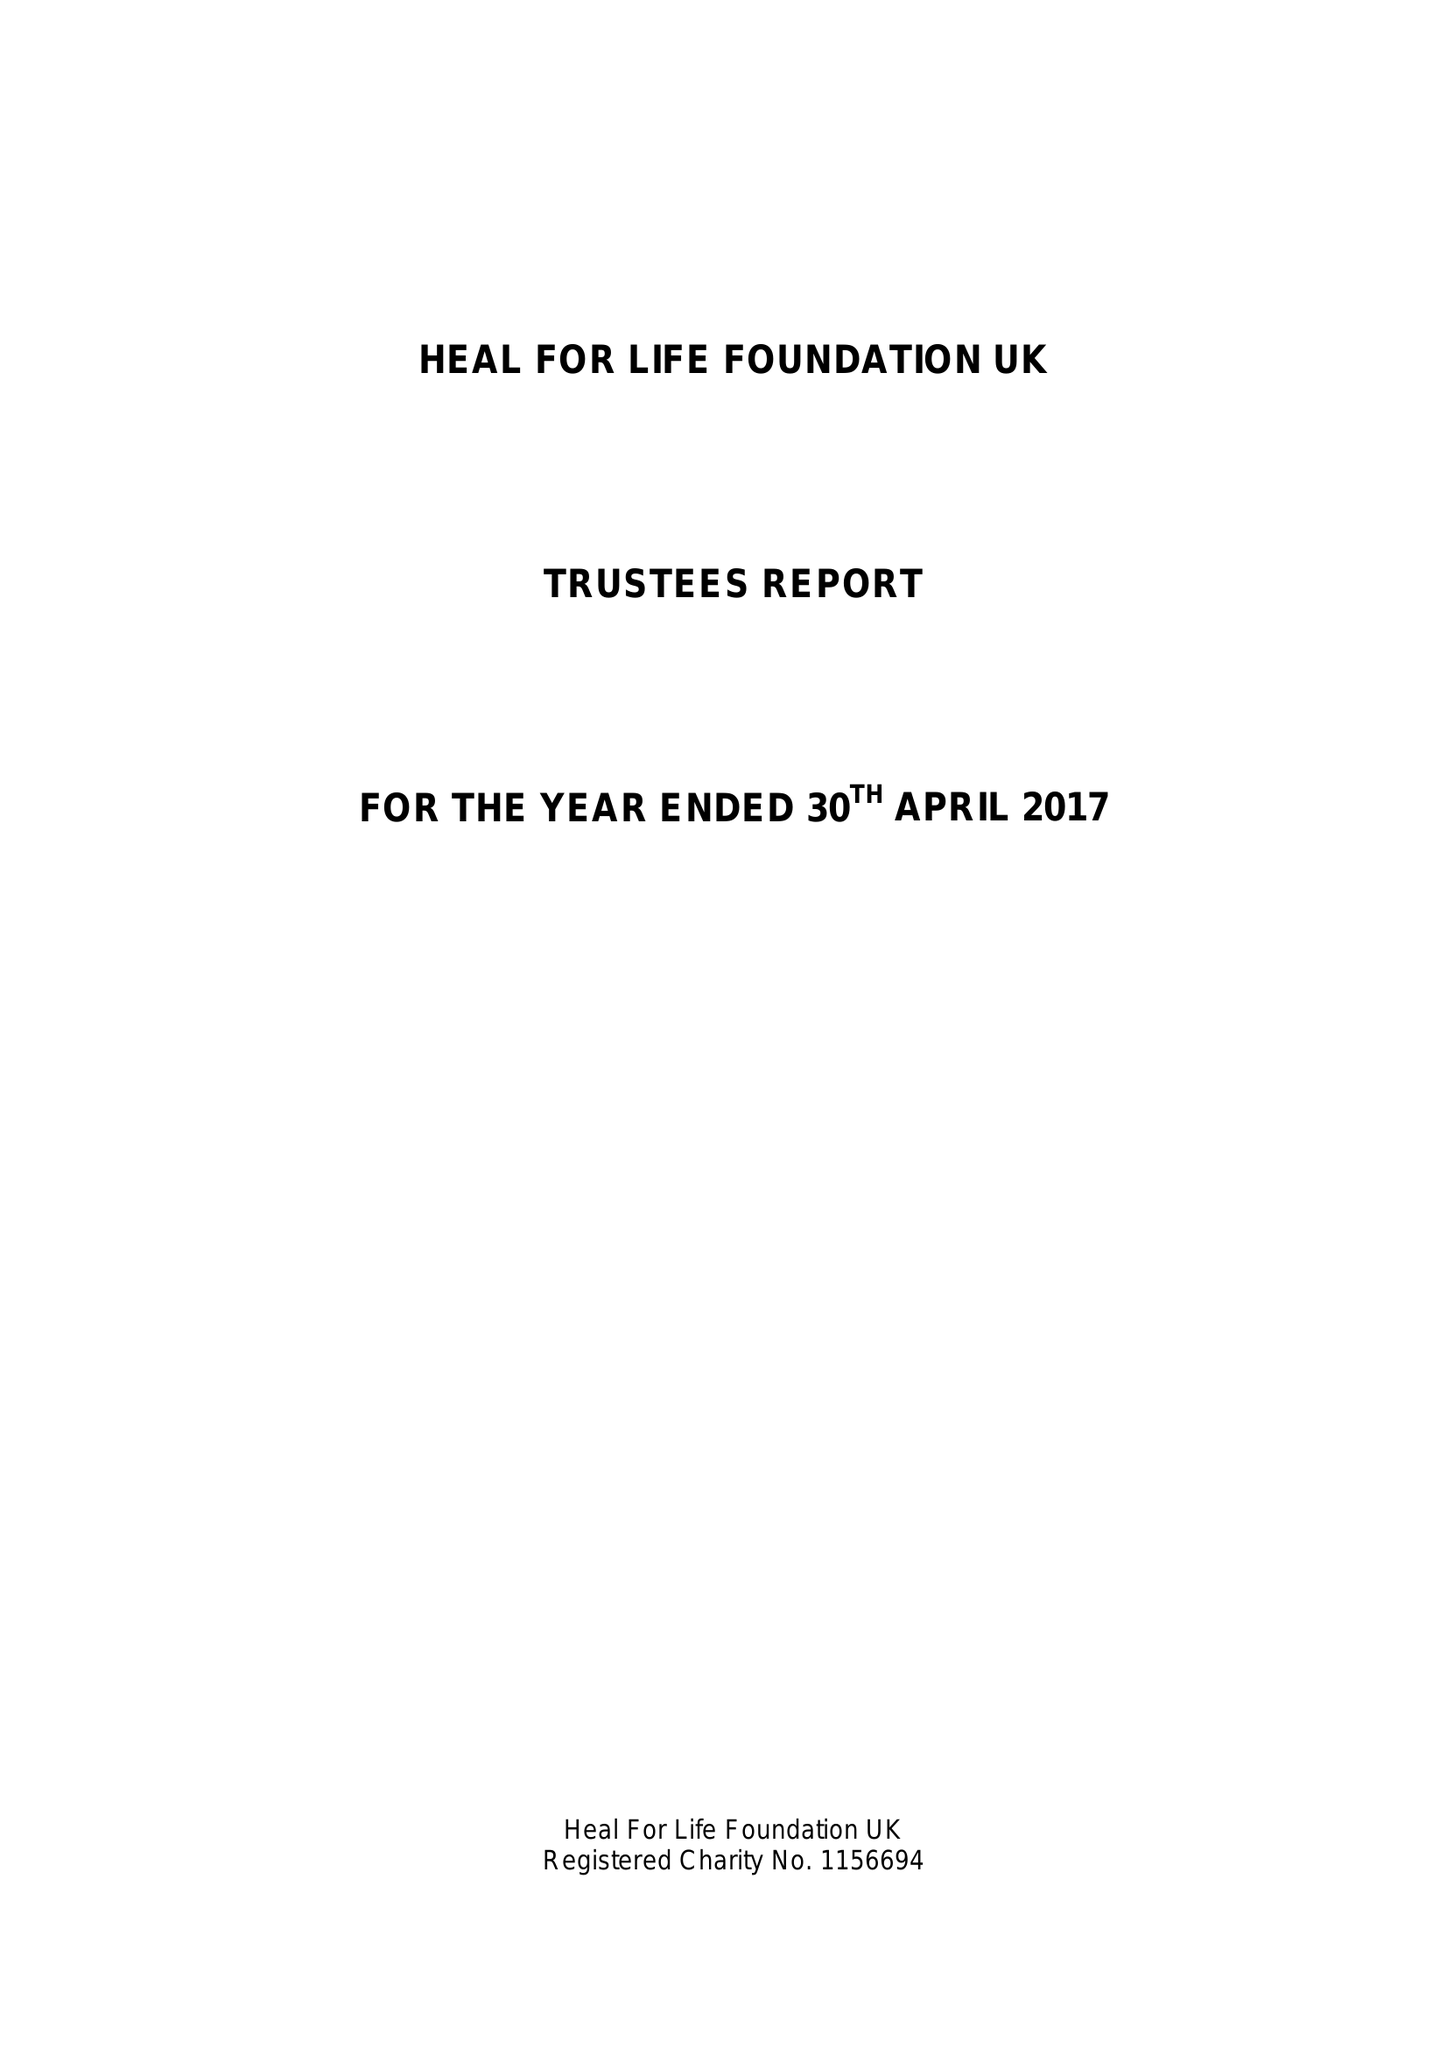What is the value for the spending_annually_in_british_pounds?
Answer the question using a single word or phrase. 9782.33 